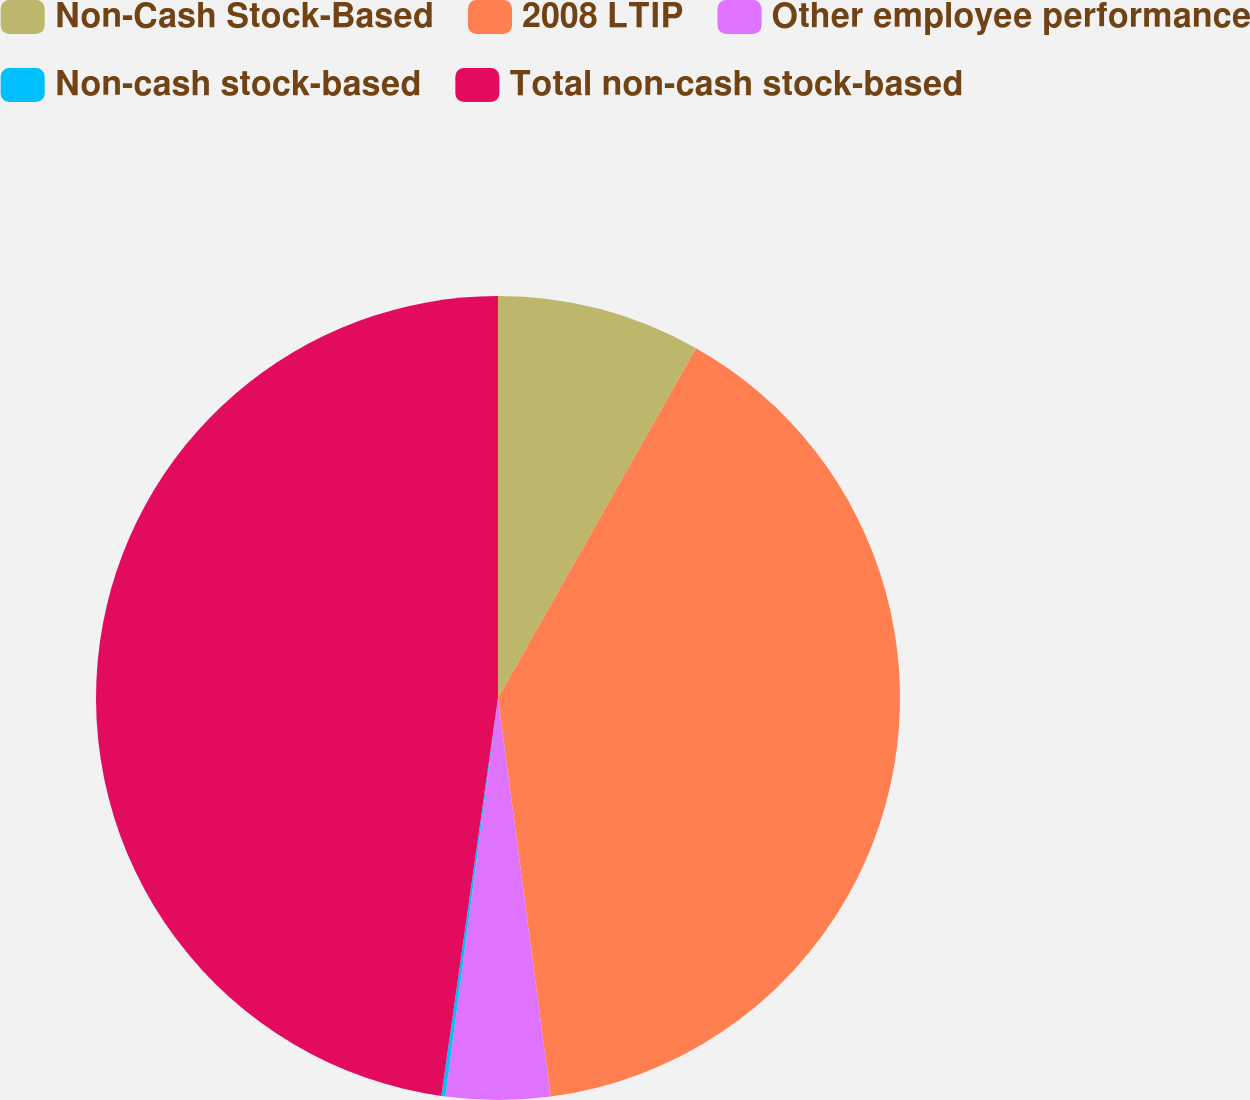Convert chart. <chart><loc_0><loc_0><loc_500><loc_500><pie_chart><fcel>Non-Cash Stock-Based<fcel>2008 LTIP<fcel>Other employee performance<fcel>Non-cash stock-based<fcel>Total non-cash stock-based<nl><fcel>8.2%<fcel>39.71%<fcel>4.18%<fcel>0.16%<fcel>47.75%<nl></chart> 